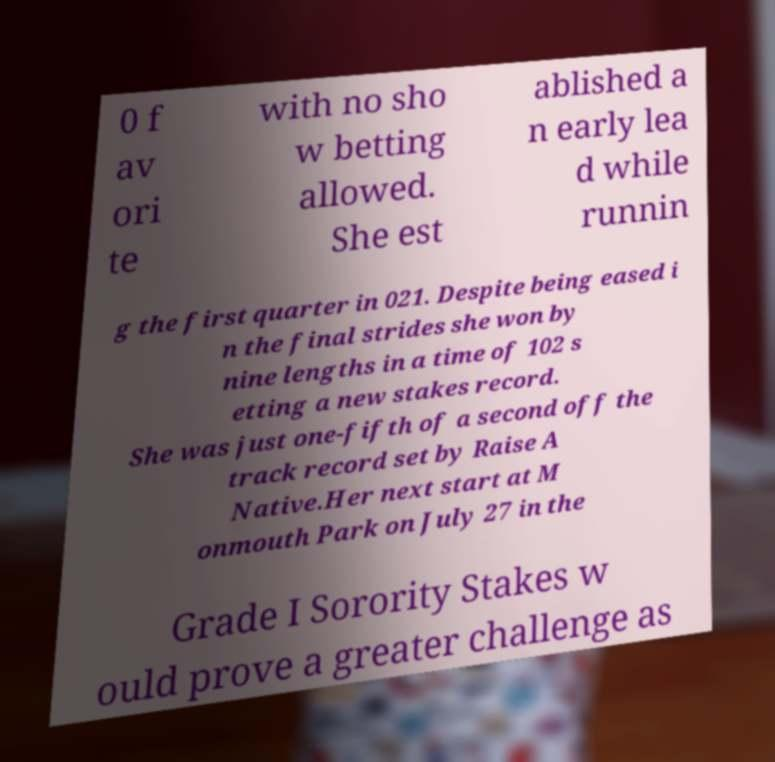Please identify and transcribe the text found in this image. 0 f av ori te with no sho w betting allowed. She est ablished a n early lea d while runnin g the first quarter in 021. Despite being eased i n the final strides she won by nine lengths in a time of 102 s etting a new stakes record. She was just one-fifth of a second off the track record set by Raise A Native.Her next start at M onmouth Park on July 27 in the Grade I Sorority Stakes w ould prove a greater challenge as 